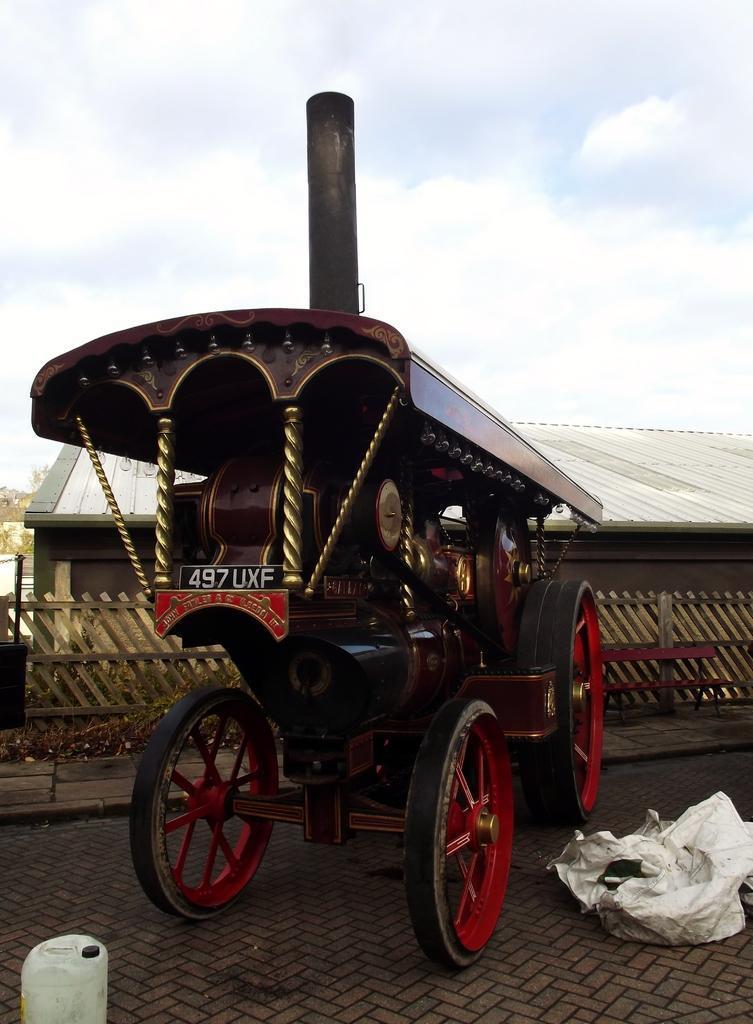How would you summarize this image in a sentence or two? In this image there is a cart on the ground. Beside the car there is a plastic sheet on the ground. In the bottom left there is a can. There is text on the cart. Behind the cart there is a wooden railing. In the background there is a house. At the top there is the sky. 